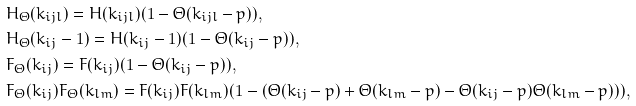Convert formula to latex. <formula><loc_0><loc_0><loc_500><loc_500>& H _ { \Theta } ( k _ { i j l } ) = H ( k _ { i j l } ) ( 1 - \Theta ( k _ { i j l } - p ) ) , \\ & H _ { \Theta } ( k _ { i j } - 1 ) = H ( k _ { i j } - 1 ) ( 1 - \Theta ( k _ { i j } - p ) ) , \\ & F _ { \Theta } ( k _ { i j } ) = F ( k _ { i j } ) ( 1 - \Theta ( k _ { i j } - p ) ) , \\ & F _ { \Theta } ( k _ { i j } ) F _ { \Theta } ( k _ { l m } ) = F ( k _ { i j } ) F ( k _ { l m } ) ( 1 - ( \Theta ( k _ { i j } - p ) + \Theta ( k _ { l m } - p ) - \Theta ( k _ { i j } - p ) \Theta ( k _ { l m } - p ) ) ) ,</formula> 